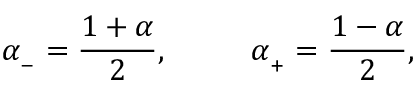Convert formula to latex. <formula><loc_0><loc_0><loc_500><loc_500>\alpha _ { _ { - } } = \frac { 1 + \alpha } { 2 } , \quad \alpha _ { _ { + } } = \frac { 1 - \alpha } { 2 } ,</formula> 